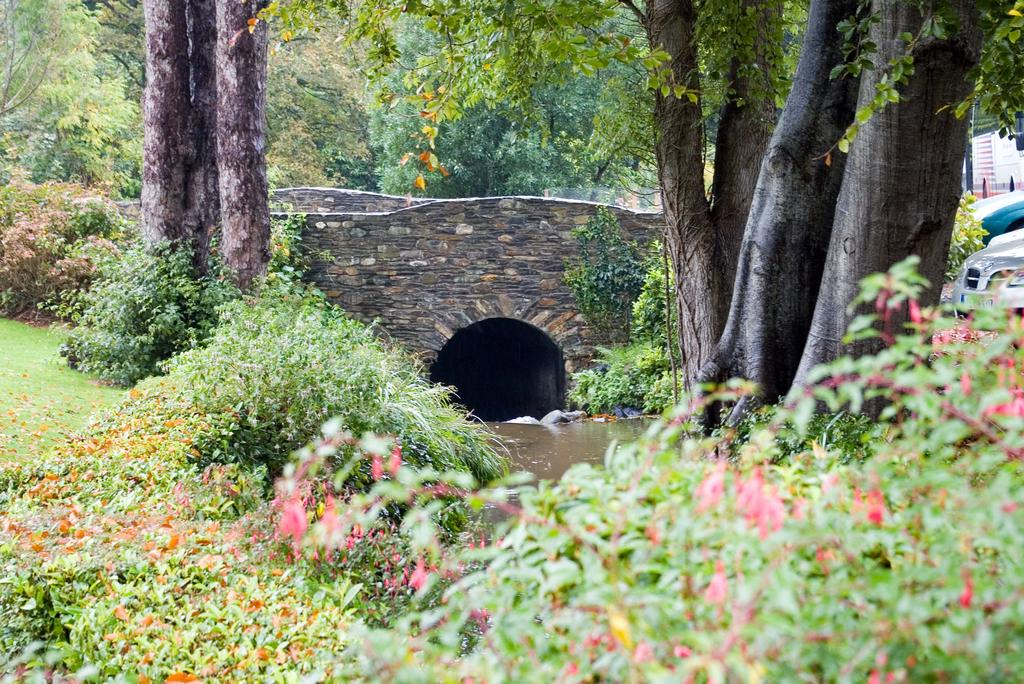What type of vegetation can be seen in the image? There are trees in the image. What is the color of the trees? The trees are green in color. What else is present in the image besides trees? There are vehicles in the image. What can be seen in the background of the image? There is a cave visible in the background of the image. Can you see a face carved into the trees in the image? There is no face carved into the trees in the image; the trees are simply green in color. 